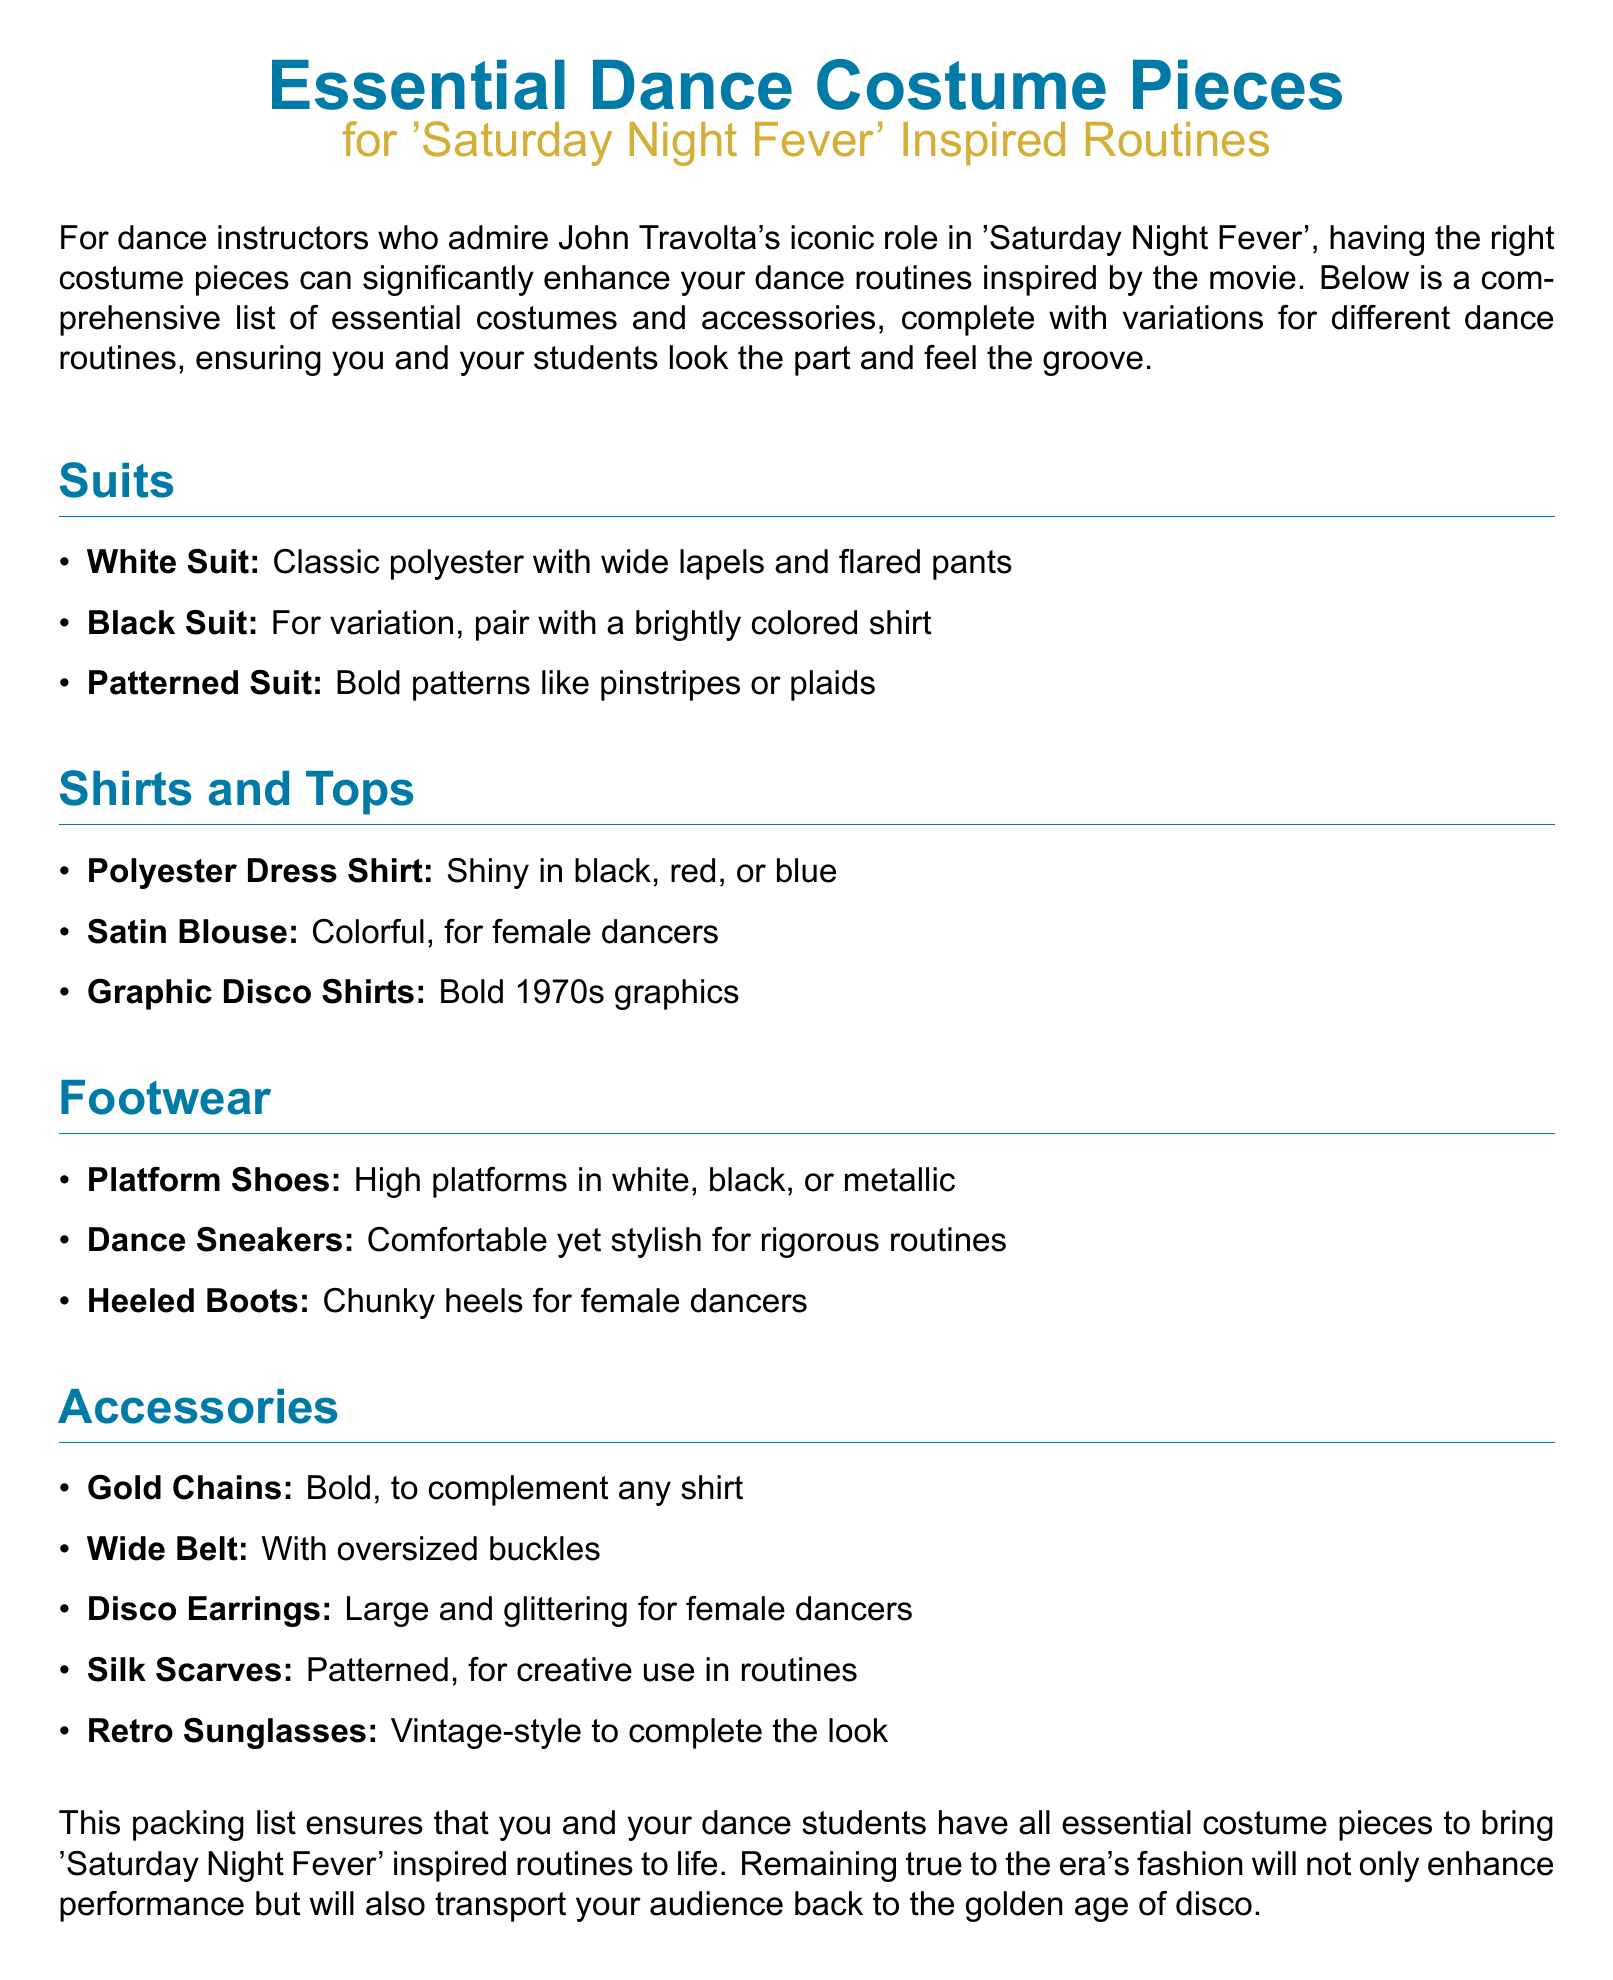what is the color of the classic suit? The classic suit mentioned is being a white suit, specifically described as "Classic polyester with wide lapels and flared pants."
Answer: White Suit what type of footwear is recommended for rigorous routines? The document suggests "Dance Sneakers" as comfortable yet stylish footwear for rigorous routines.
Answer: Dance Sneakers which accessory can complement any shirt? The document states that "Gold Chains" are bold accessories that can complement any shirt.
Answer: Gold Chains how many types of suits are listed? There are three types of suits listed: White Suit, Black Suit, and Patterned Suit.
Answer: Three which shirt is specified for female dancers? A "Satin Blouse" is specifically mentioned for female dancers.
Answer: Satin Blouse what material is the recommended dress shirt made from? The recommended dress shirt is made of "Polyester," which is mentioned in the document.
Answer: Polyester what type of shoes does the document emphasize for their height? The document emphasizes "Platform Shoes," which are high platforms in various colors.
Answer: Platform Shoes what is a popular pattern mentioned for suits? The document references "Bold patterns like pinstripes or plaids" as suitable for patterned suits.
Answer: Pinstripes what type of sunglasses are suggested for the look? "Retro Sunglasses" are suggested to complete the disco look in the document.
Answer: Retro Sunglasses 